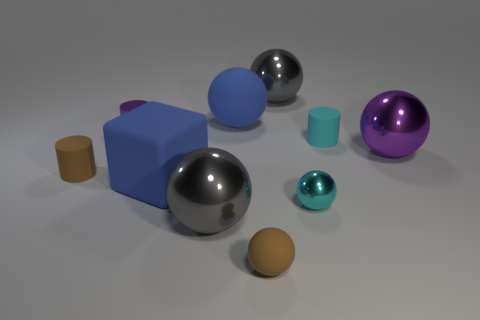Are there any small cyan things made of the same material as the big purple thing?
Your answer should be compact. Yes. How many cylinders are tiny cyan rubber objects or purple metallic objects?
Your answer should be very brief. 2. Are there any small purple things on the right side of the small metallic object that is behind the big purple metal sphere?
Provide a short and direct response. No. Is the number of purple things less than the number of tiny cyan metal balls?
Keep it short and to the point. No. How many small shiny things are the same shape as the cyan matte thing?
Make the answer very short. 1. What number of blue objects are rubber cubes or big metallic spheres?
Your answer should be compact. 1. What size is the brown object left of the blue object behind the large purple object?
Your response must be concise. Small. What is the material of the tiny cyan thing that is the same shape as the large purple thing?
Your answer should be compact. Metal. What number of other brown rubber balls have the same size as the brown rubber sphere?
Provide a succinct answer. 0. Do the blue rubber block and the purple shiny cylinder have the same size?
Provide a succinct answer. No. 